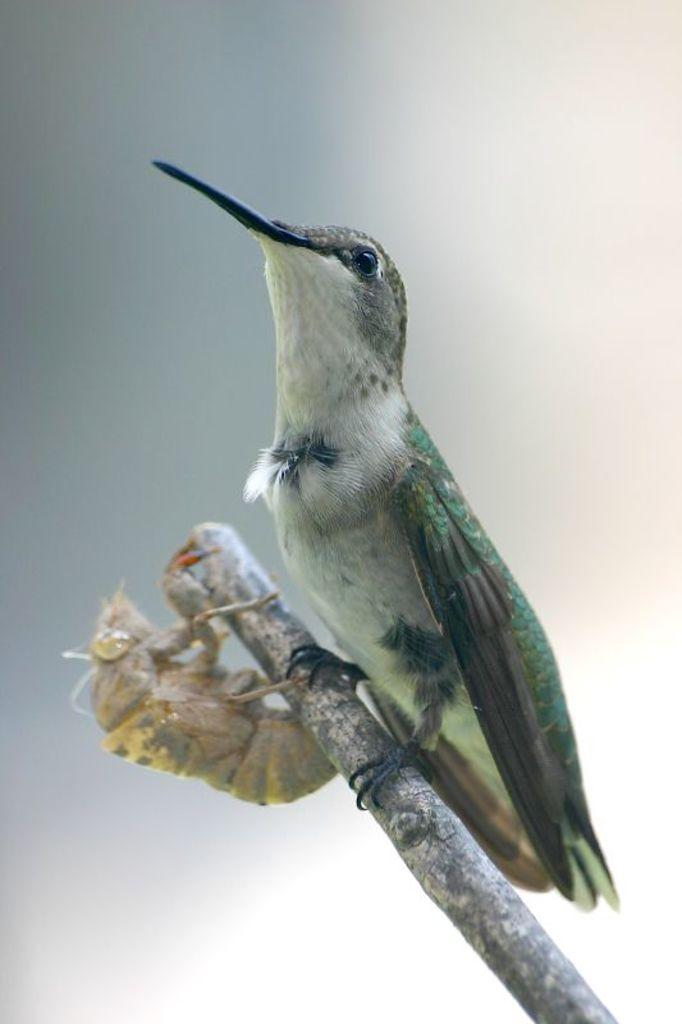What type of animal can be seen in the image? There is a bird in the image. What other object can be seen in the image? There is a pupa in the image. Where are the bird and pupa located? Both the bird and pupa are on a wooden stick. What can be seen in the background of the image? The sky is visible in the background of the image. Where can the needle be found in the image? There is no needle present in the image. What type of store can be seen in the background of the image? There is no store visible in the image; only the sky is visible in the background. 